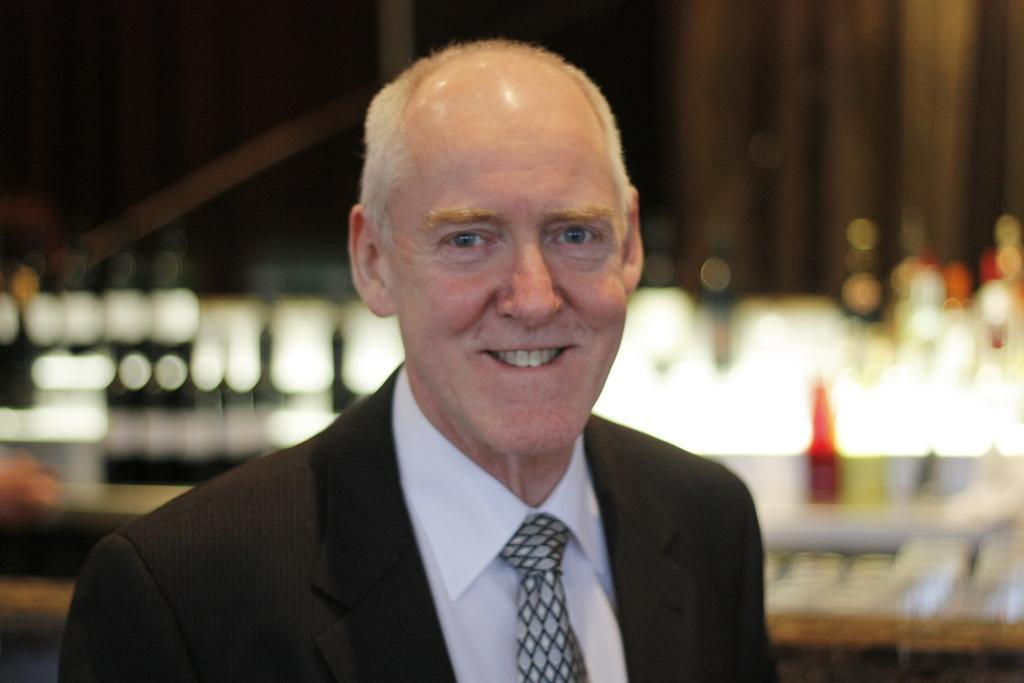How would you summarize this image in a sentence or two? In this image we can see a man and he is smiling. There is a blur background. 